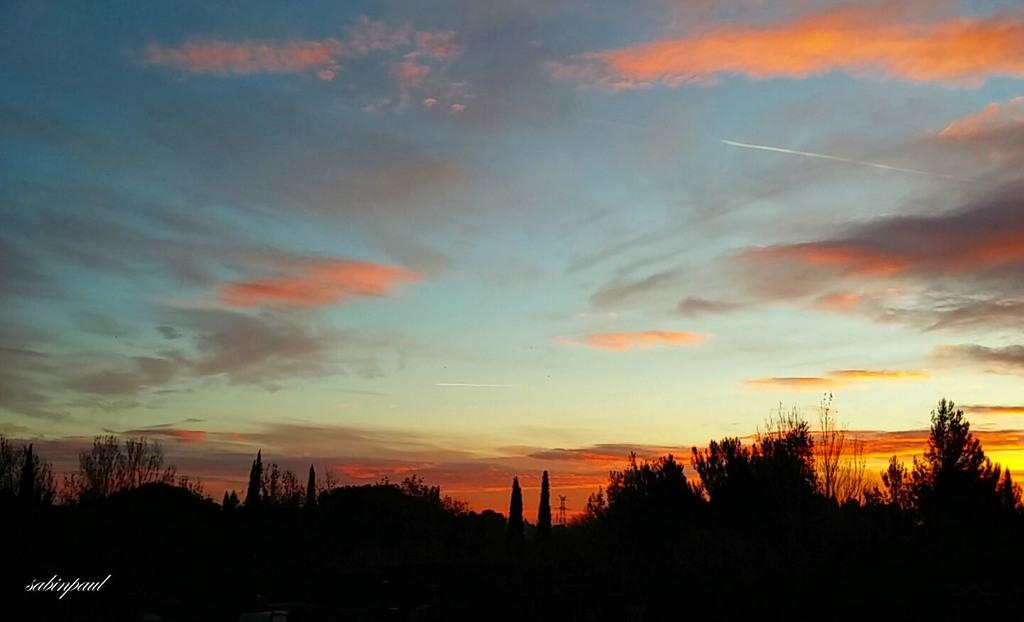What type of living organisms can be seen in the image? Plants can be seen in the image. What can be seen in the sky in the image? There are clouds in the sky in the image. Is there any text or marking on the image? Yes, there is a watermark on the left side of the image. What type of weather condition, such as sleet, can be seen in the image? There is no indication of sleet or any specific weather condition in the image; only clouds are visible in the sky. 